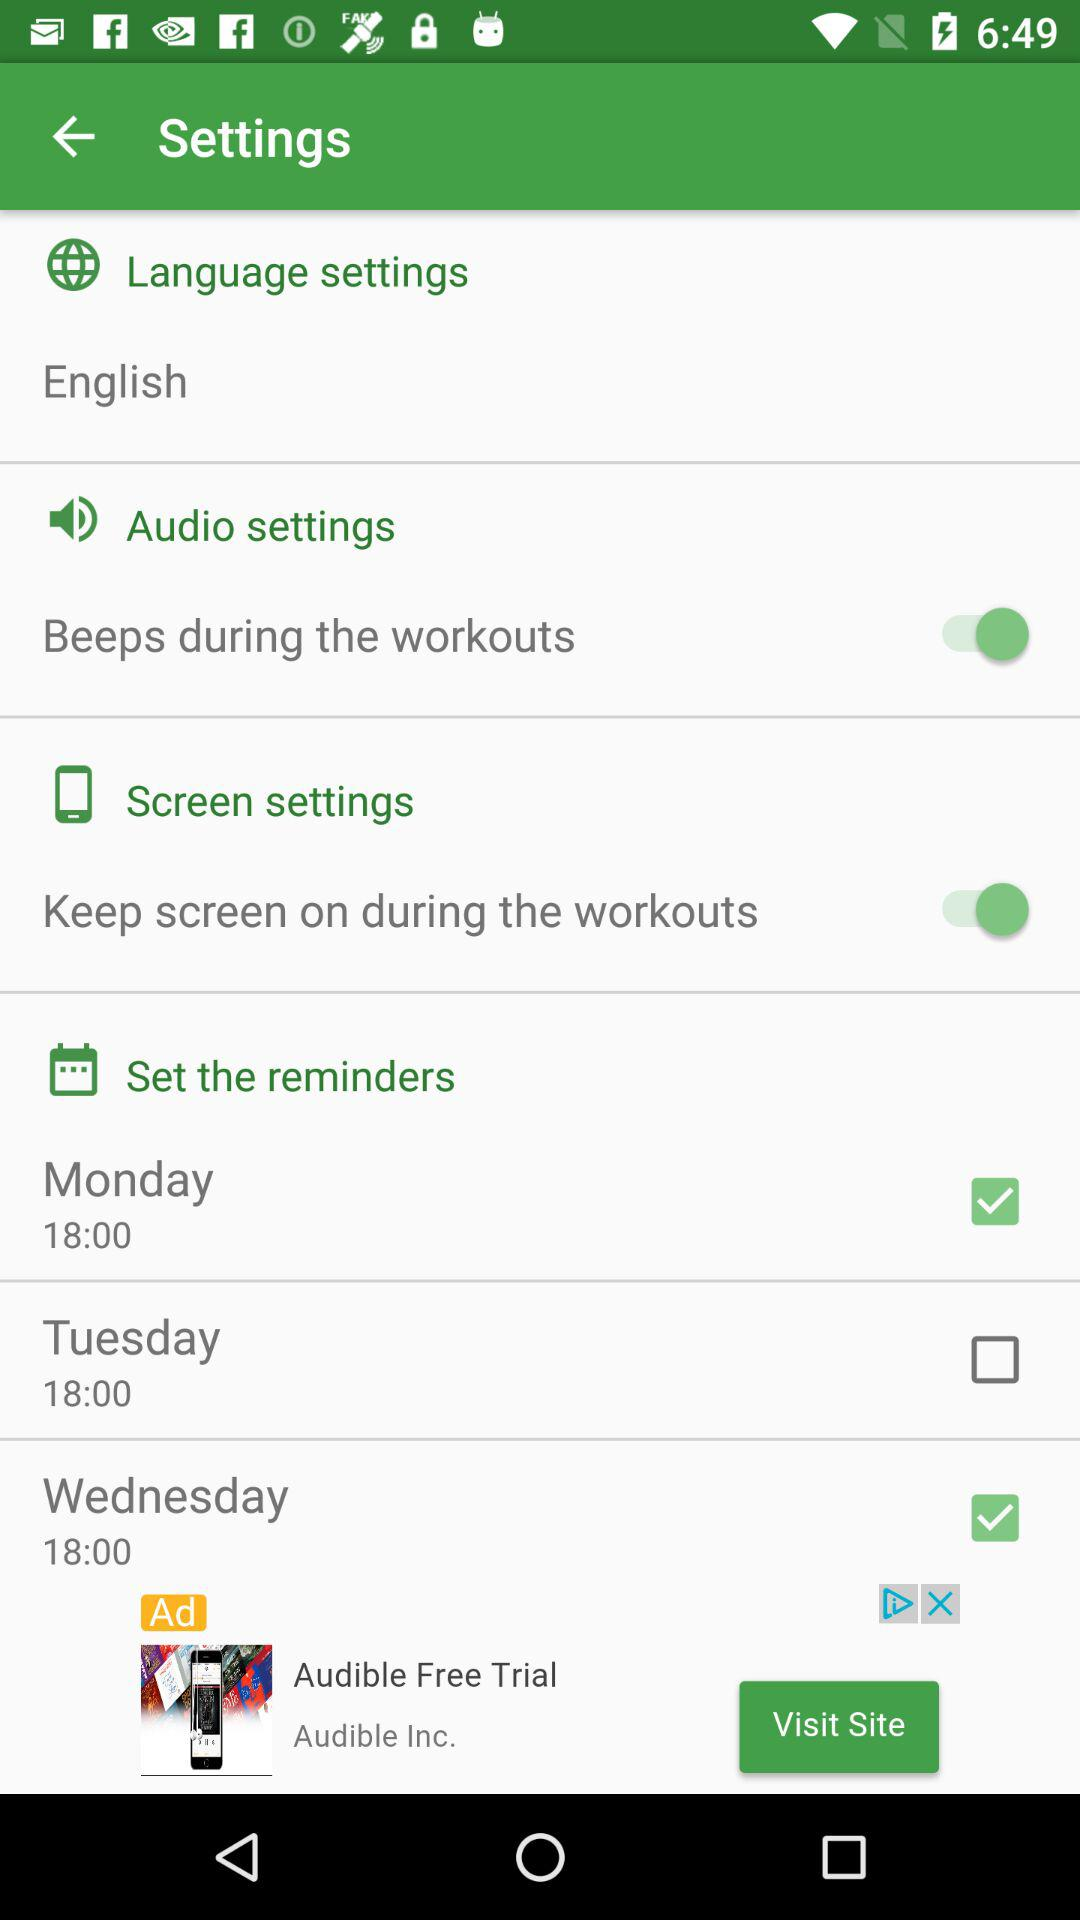What is the status of "Screen settings"? The status of "Screen settings" is "on". 